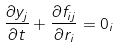Convert formula to latex. <formula><loc_0><loc_0><loc_500><loc_500>\frac { \partial y _ { j } } { \partial t } + \frac { \partial f _ { i j } } { \partial r _ { i } } = 0 _ { i }</formula> 